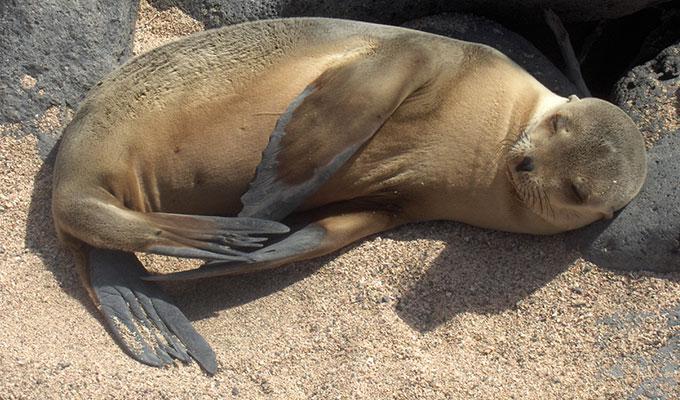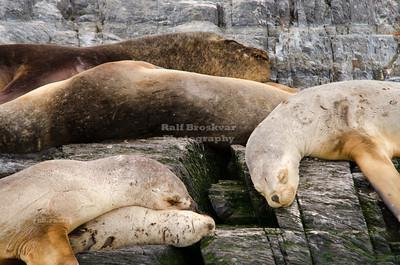The first image is the image on the left, the second image is the image on the right. Considering the images on both sides, is "There are exactly two seals in the right image." valid? Answer yes or no. No. The first image is the image on the left, the second image is the image on the right. Considering the images on both sides, is "A black seal is sitting to the right of a brown seal." valid? Answer yes or no. No. 